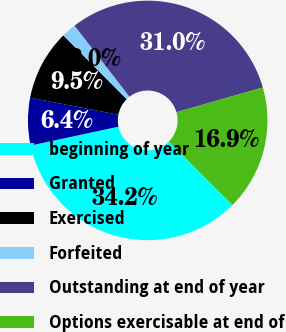Convert chart to OTSL. <chart><loc_0><loc_0><loc_500><loc_500><pie_chart><fcel>beginning of year<fcel>Granted<fcel>Exercised<fcel>Forfeited<fcel>Outstanding at end of year<fcel>Options exercisable at end of<nl><fcel>34.16%<fcel>6.4%<fcel>9.53%<fcel>1.97%<fcel>31.03%<fcel>16.91%<nl></chart> 